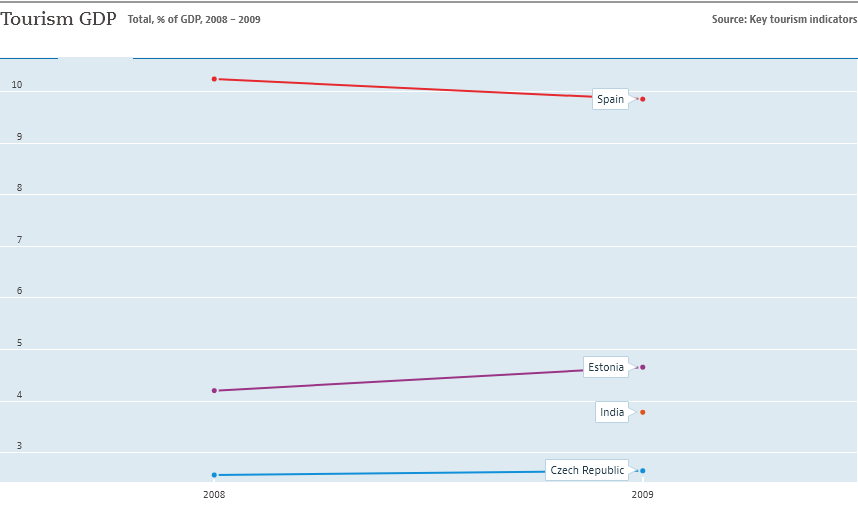Identify some key points in this picture. The graph includes four countries. The sum of all lines becomes biggest in the year 2009. 